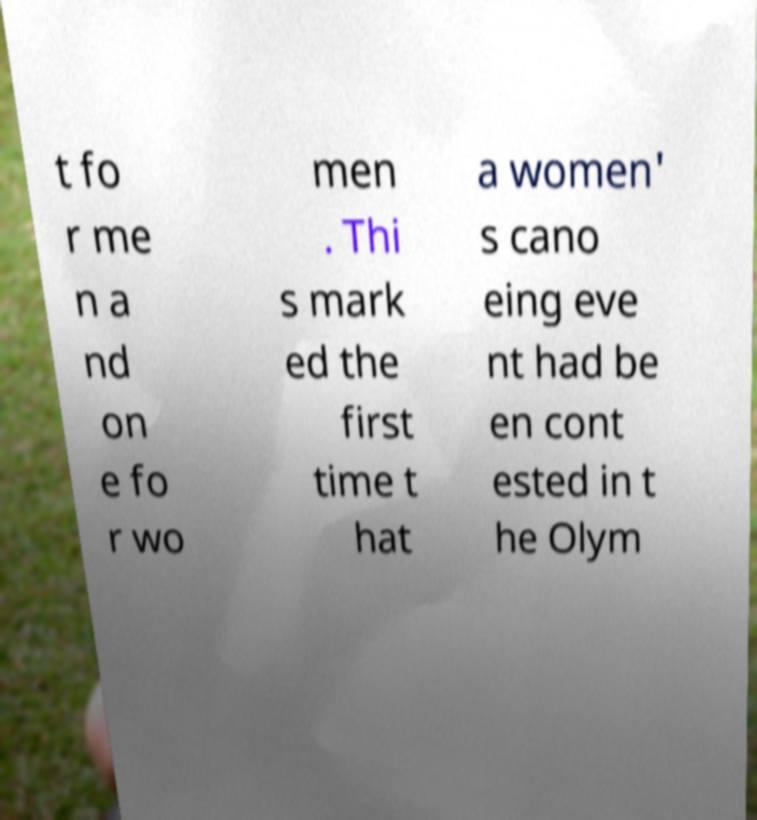I need the written content from this picture converted into text. Can you do that? t fo r me n a nd on e fo r wo men . Thi s mark ed the first time t hat a women' s cano eing eve nt had be en cont ested in t he Olym 